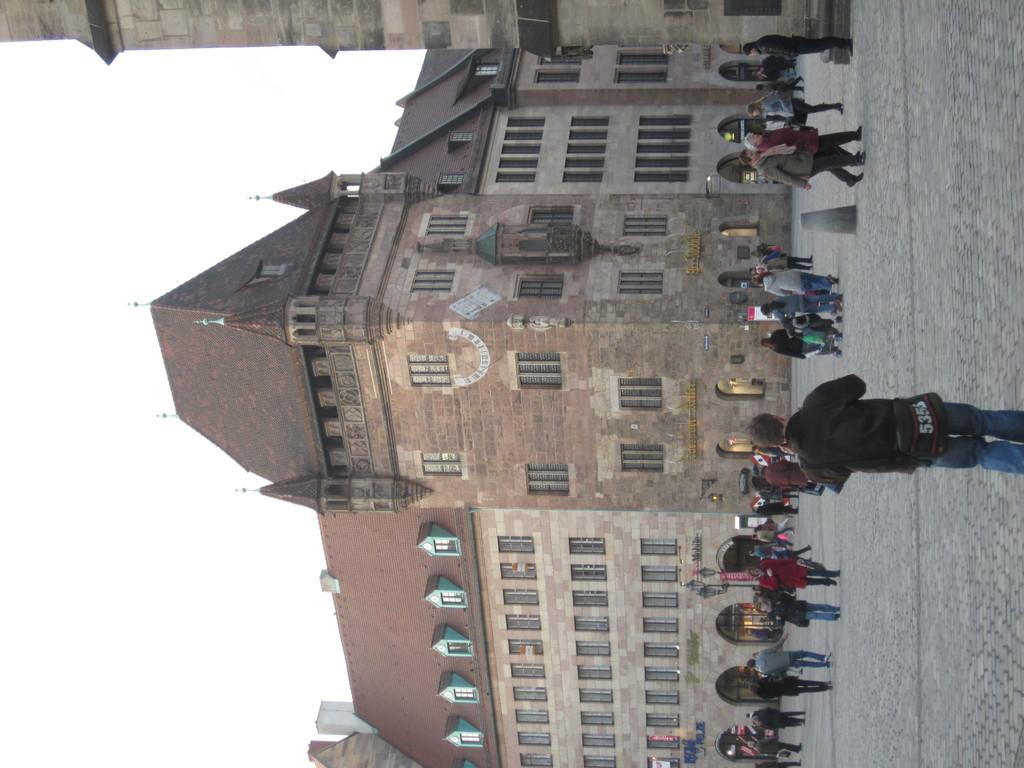What is happening on the road in the image? There are people on the road in the image. What else can be seen in the image besides the people on the road? There are buildings visible in the image. What is visible in the background of the image? The sky is visible in the image. What type of creature can be seen writing in a notebook in the image? There is no creature present in the image, nor is there a notebook. 